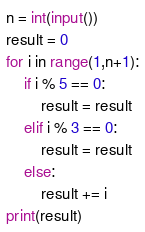Convert code to text. <code><loc_0><loc_0><loc_500><loc_500><_Python_>n = int(input())
result = 0
for i in range(1,n+1):
    if i % 5 == 0:
        result = result
    elif i % 3 == 0:
        result = result
    else:
        result += i
print(result)</code> 